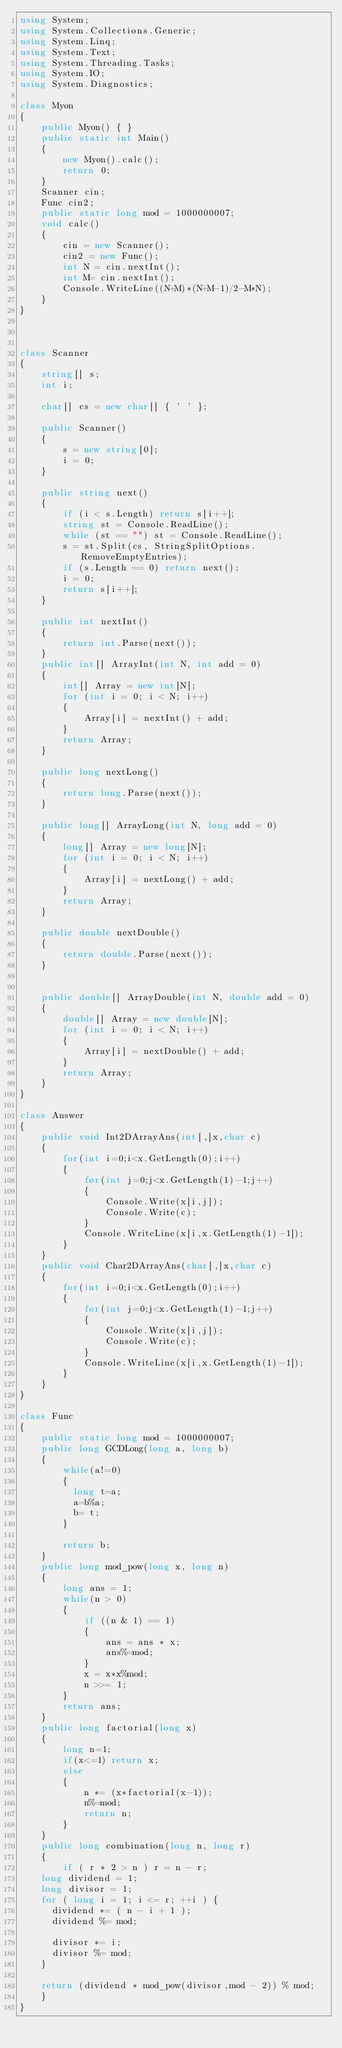Convert code to text. <code><loc_0><loc_0><loc_500><loc_500><_C#_>using System;
using System.Collections.Generic;
using System.Linq;
using System.Text;
using System.Threading.Tasks;
using System.IO;
using System.Diagnostics;

class Myon
{
    public Myon() { }
    public static int Main()
    {
        new Myon().calc();
        return 0;
    }
    Scanner cin;
    Func cin2;
    public static long mod = 1000000007;
    void calc()
    {
        cin = new Scanner();
        cin2 = new Func();
        int N = cin.nextInt();
        int M= cin.nextInt();
        Console.WriteLine((N+M)*(N+M-1)/2-M*N);
    }
}



class Scanner
{
    string[] s;
    int i;

    char[] cs = new char[] { ' ' };

    public Scanner()
    {
        s = new string[0];
        i = 0;
    }

    public string next()
    {
        if (i < s.Length) return s[i++];
        string st = Console.ReadLine();
        while (st == "") st = Console.ReadLine();
        s = st.Split(cs, StringSplitOptions.RemoveEmptyEntries);
        if (s.Length == 0) return next();
        i = 0;
        return s[i++];
    }

    public int nextInt()
    {
        return int.Parse(next());
    }
    public int[] ArrayInt(int N, int add = 0)
    {
        int[] Array = new int[N];
        for (int i = 0; i < N; i++)
        {
            Array[i] = nextInt() + add;
        }
        return Array;
    }

    public long nextLong()
    {
        return long.Parse(next());
    }

    public long[] ArrayLong(int N, long add = 0)
    {
        long[] Array = new long[N];
        for (int i = 0; i < N; i++)
        {
            Array[i] = nextLong() + add;
        }
        return Array;
    }

    public double nextDouble()
    {
        return double.Parse(next());
    }


    public double[] ArrayDouble(int N, double add = 0)
    {
        double[] Array = new double[N];
        for (int i = 0; i < N; i++)
        {
            Array[i] = nextDouble() + add;
        }
        return Array;
    }
}

class Answer
{
    public void Int2DArrayAns(int[,]x,char c)
    {
        for(int i=0;i<x.GetLength(0);i++)
        {
            for(int j=0;j<x.GetLength(1)-1;j++)
            {
                Console.Write(x[i,j]);
                Console.Write(c);
            }
            Console.WriteLine(x[i,x.GetLength(1)-1]);
        }
    }
    public void Char2DArrayAns(char[,]x,char c)
    {
        for(int i=0;i<x.GetLength(0);i++)
        {
            for(int j=0;j<x.GetLength(1)-1;j++)
            {
                Console.Write(x[i,j]);
                Console.Write(c);
            }
            Console.WriteLine(x[i,x.GetLength(1)-1]);
        }
    }
}

class Func
{
    public static long mod = 1000000007;
    public long GCDLong(long a, long b)
    {
        while(a!=0)
        {
          long t=a;
          a=b%a;
          b= t;
        }
      
        return b;        
    }
    public long mod_pow(long x, long n)
    { 
        long ans = 1;
        while(n > 0)
        {
            if ((n & 1) == 1)
            {
                ans = ans * x;
                ans%=mod;
            }
            x = x*x%mod;
            n >>= 1;
        }
        return ans;
    }
    public long factorial(long x)
    {
        long n=1;
        if(x<=1) return x;
        else
        {
            n *= (x*factorial(x-1));
            n%=mod;
            return n;
        }
    }
    public long combination(long n, long r)
    {
        if ( r * 2 > n ) r = n - r;
		long dividend = 1;
		long divisor = 1;
		for ( long i = 1; i <= r; ++i ) {
			dividend *= ( n - i + 1 );
			dividend %= mod;
 
			divisor *= i;
			divisor %= mod;
		}
 
		return (dividend * mod_pow(divisor,mod - 2)) % mod;   
    }
}


</code> 